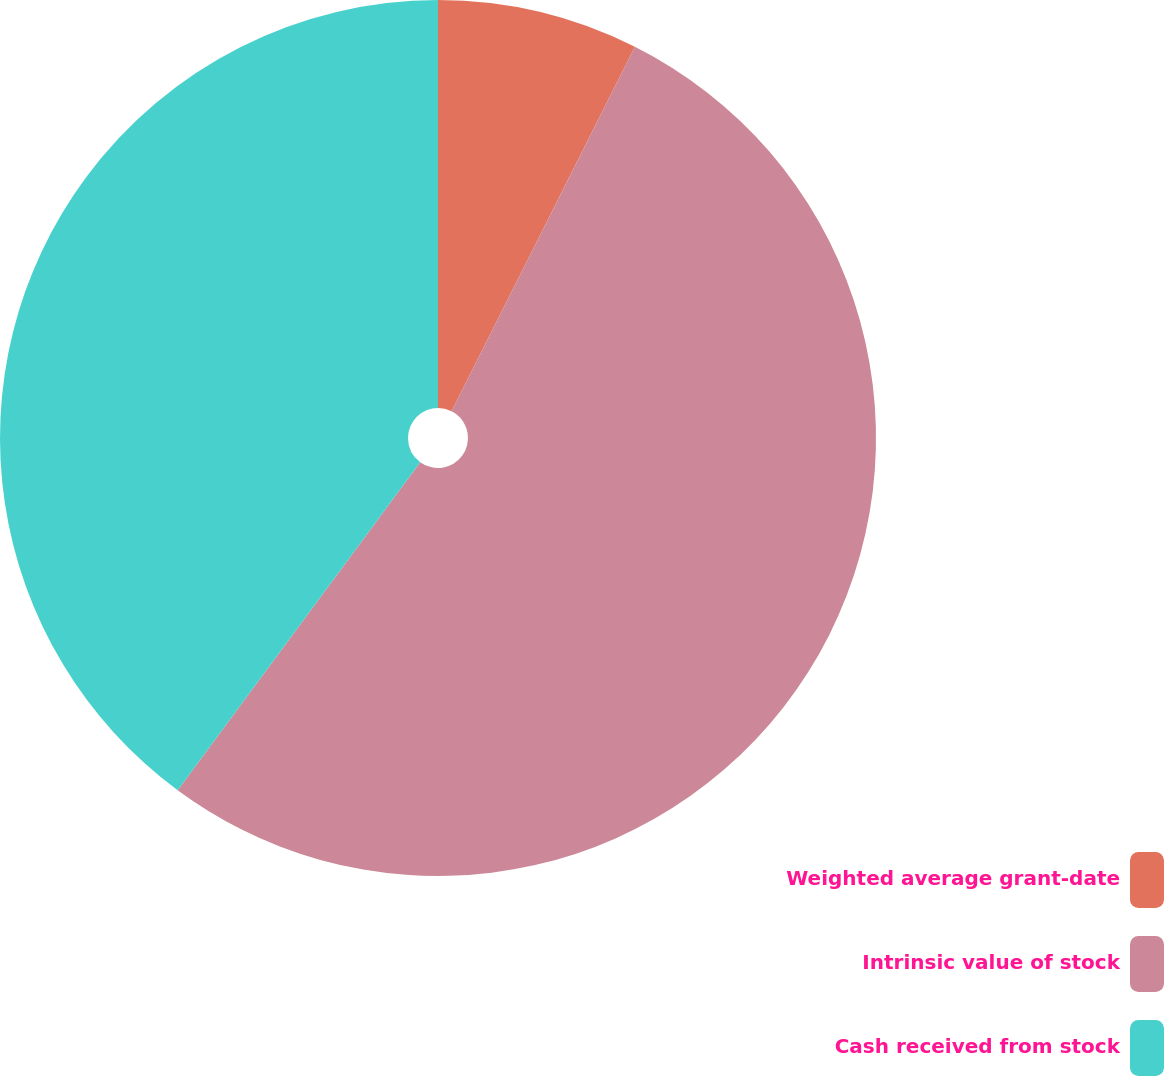Convert chart. <chart><loc_0><loc_0><loc_500><loc_500><pie_chart><fcel>Weighted average grant-date<fcel>Intrinsic value of stock<fcel>Cash received from stock<nl><fcel>7.42%<fcel>52.71%<fcel>39.87%<nl></chart> 